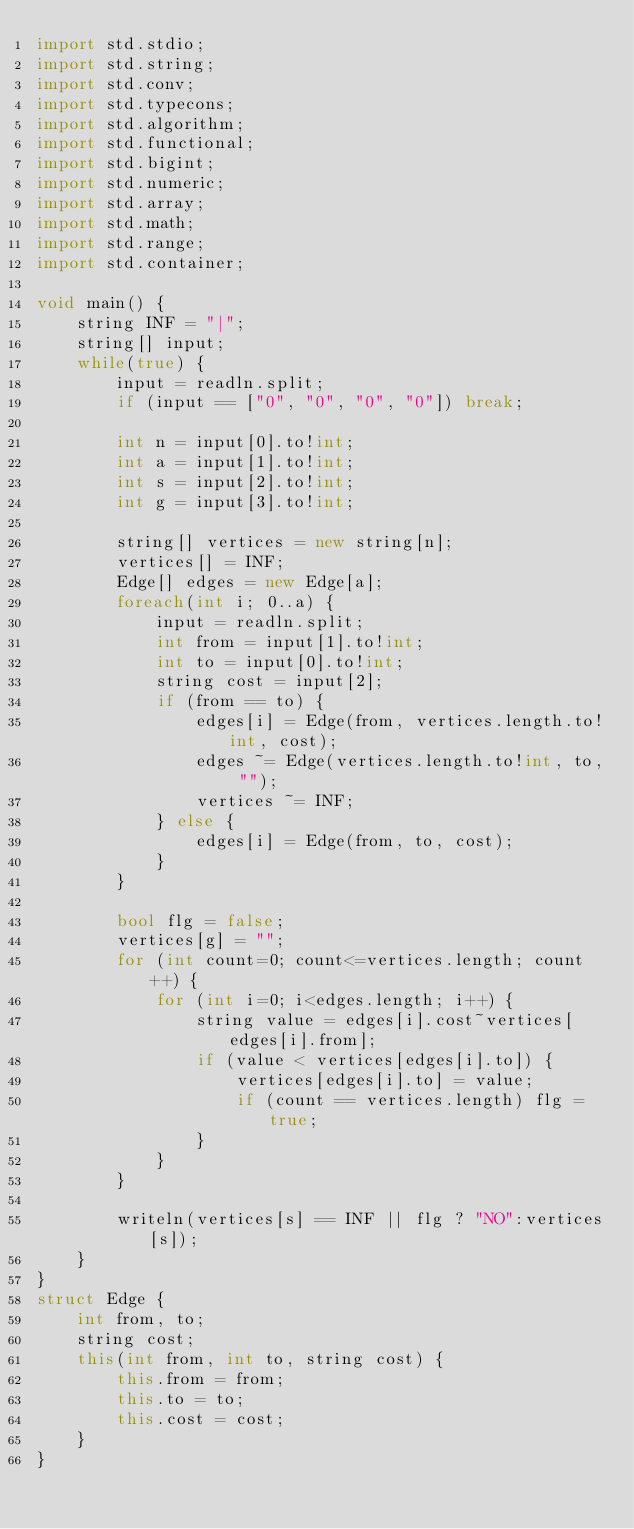<code> <loc_0><loc_0><loc_500><loc_500><_D_>import std.stdio;
import std.string;
import std.conv;
import std.typecons;
import std.algorithm;
import std.functional;
import std.bigint;
import std.numeric;
import std.array;
import std.math;
import std.range;
import std.container;

void main() {
    string INF = "|";
    string[] input;
    while(true) {
        input = readln.split;
        if (input == ["0", "0", "0", "0"]) break;

        int n = input[0].to!int;
        int a = input[1].to!int;
        int s = input[2].to!int;
        int g = input[3].to!int;

        string[] vertices = new string[n];
        vertices[] = INF;
        Edge[] edges = new Edge[a];
        foreach(int i; 0..a) {
            input = readln.split;
            int from = input[1].to!int;
            int to = input[0].to!int;
            string cost = input[2];
            if (from == to) {
                edges[i] = Edge(from, vertices.length.to!int, cost);
                edges ~= Edge(vertices.length.to!int, to, "");
                vertices ~= INF;
            } else {
                edges[i] = Edge(from, to, cost);
            }
        }

        bool flg = false;
        vertices[g] = "";
        for (int count=0; count<=vertices.length; count++) {
            for (int i=0; i<edges.length; i++) {
                string value = edges[i].cost~vertices[edges[i].from];
                if (value < vertices[edges[i].to]) {
                    vertices[edges[i].to] = value;
                    if (count == vertices.length) flg = true;
                }
            }
        }

        writeln(vertices[s] == INF || flg ? "NO":vertices[s]);
    }
}
struct Edge {
    int from, to;
    string cost;
    this(int from, int to, string cost) {
        this.from = from;
        this.to = to;
        this.cost = cost;
    }
}</code> 